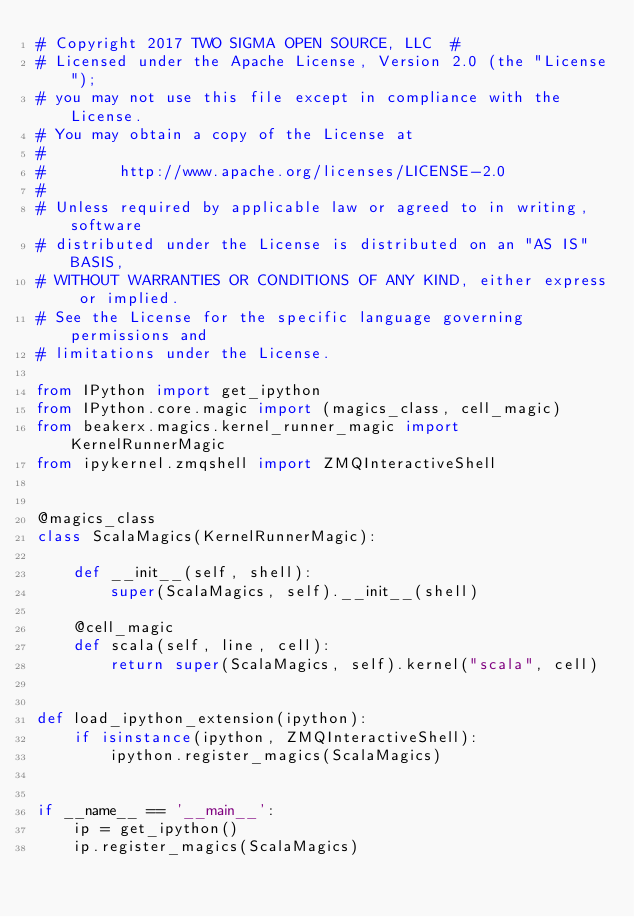Convert code to text. <code><loc_0><loc_0><loc_500><loc_500><_Python_># Copyright 2017 TWO SIGMA OPEN SOURCE, LLC  #
# Licensed under the Apache License, Version 2.0 (the "License");
# you may not use this file except in compliance with the License.
# You may obtain a copy of the License at
#
#        http://www.apache.org/licenses/LICENSE-2.0
#
# Unless required by applicable law or agreed to in writing, software
# distributed under the License is distributed on an "AS IS" BASIS,
# WITHOUT WARRANTIES OR CONDITIONS OF ANY KIND, either express or implied.
# See the License for the specific language governing permissions and
# limitations under the License.

from IPython import get_ipython
from IPython.core.magic import (magics_class, cell_magic)
from beakerx.magics.kernel_runner_magic import KernelRunnerMagic
from ipykernel.zmqshell import ZMQInteractiveShell


@magics_class
class ScalaMagics(KernelRunnerMagic):

    def __init__(self, shell):
        super(ScalaMagics, self).__init__(shell)

    @cell_magic
    def scala(self, line, cell):
        return super(ScalaMagics, self).kernel("scala", cell)


def load_ipython_extension(ipython):
    if isinstance(ipython, ZMQInteractiveShell):
        ipython.register_magics(ScalaMagics)


if __name__ == '__main__':
    ip = get_ipython()
    ip.register_magics(ScalaMagics)
</code> 